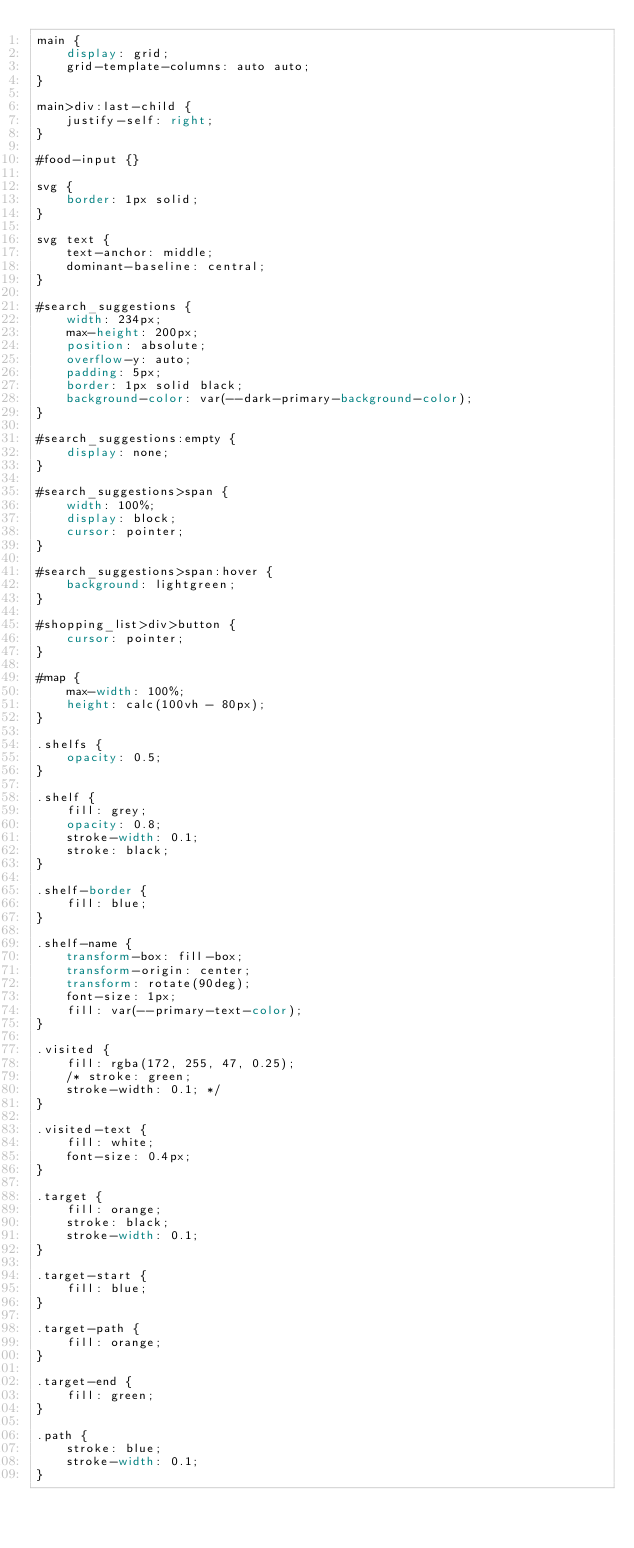<code> <loc_0><loc_0><loc_500><loc_500><_CSS_>main {
	display: grid;
	grid-template-columns: auto auto;
}

main>div:last-child {
	justify-self: right;
}

#food-input {}

svg {
	border: 1px solid;
}

svg text {
	text-anchor: middle;
	dominant-baseline: central;
}

#search_suggestions {
	width: 234px;
	max-height: 200px;
	position: absolute;
	overflow-y: auto;
	padding: 5px;
	border: 1px solid black;
	background-color: var(--dark-primary-background-color);
}

#search_suggestions:empty {
	display: none;
}

#search_suggestions>span {
	width: 100%;
	display: block;
	cursor: pointer;
}

#search_suggestions>span:hover {
	background: lightgreen;
}

#shopping_list>div>button {
	cursor: pointer;
}

#map {
	max-width: 100%;
	height: calc(100vh - 80px);
}

.shelfs {
	opacity: 0.5;
}

.shelf {
	fill: grey;
	opacity: 0.8;
	stroke-width: 0.1;
	stroke: black;
}

.shelf-border {
	fill: blue;
}

.shelf-name {
	transform-box: fill-box;
	transform-origin: center;
	transform: rotate(90deg);
	font-size: 1px;
	fill: var(--primary-text-color);
}

.visited {
	fill: rgba(172, 255, 47, 0.25);
	/* stroke: green;
	stroke-width: 0.1; */
}

.visited-text {
	fill: white;
	font-size: 0.4px;
}

.target {
	fill: orange;
	stroke: black;
	stroke-width: 0.1;
}

.target-start {
	fill: blue;
}

.target-path {
	fill: orange;
}

.target-end {
	fill: green;
}

.path {
	stroke: blue;
	stroke-width: 0.1;
}</code> 